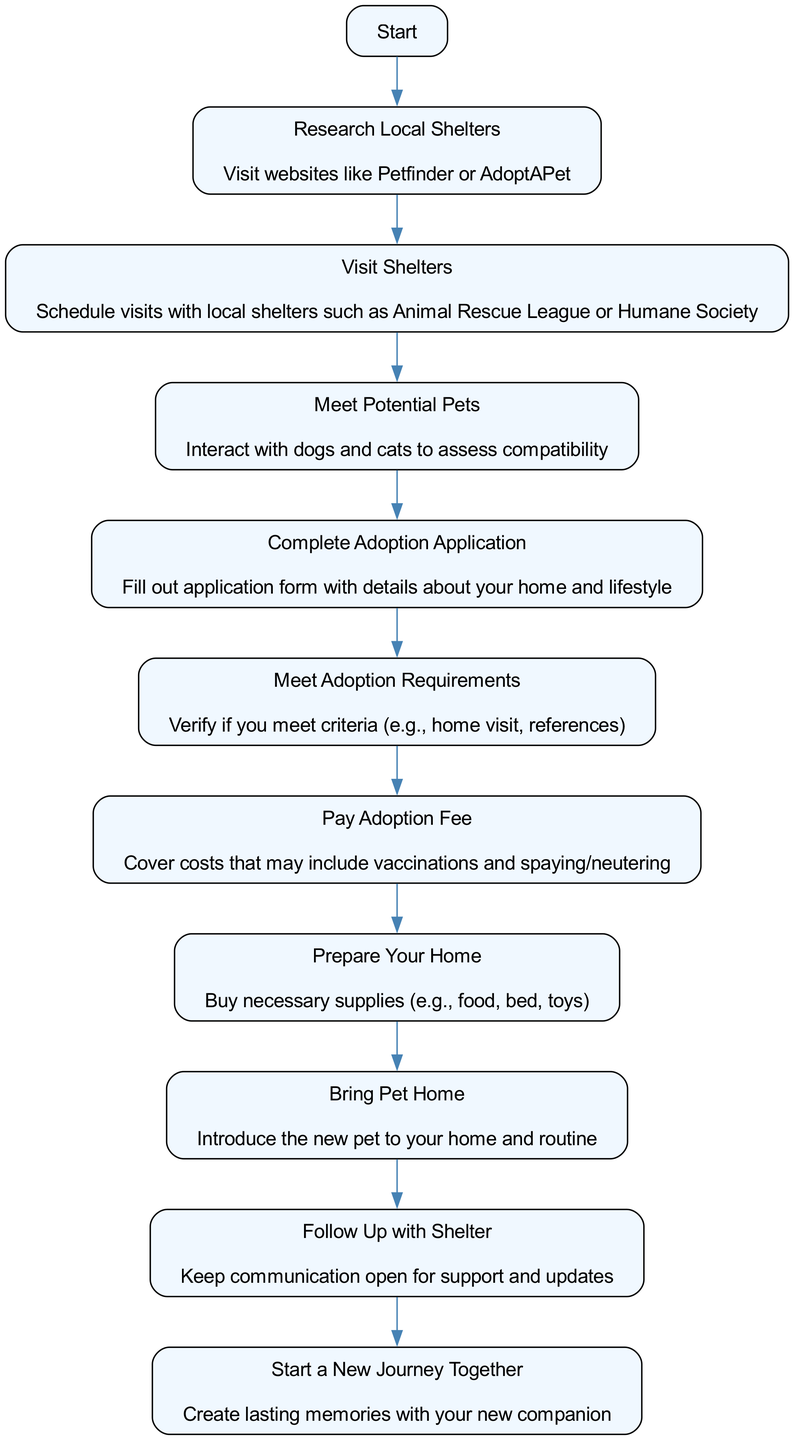What is the first step in the adoption journey? The diagram starts with the step labeled "Start," which indicates the initiation of the pet adoption process.
Answer: Start How many steps are there from research to bringing the pet home? By counting each step in the sequence from "Research Local Shelters" to "Bring Pet Home," there are 8 steps in total.
Answer: 8 What action follows "Visit Shelters"? After "Visit Shelters," the next action is "Meet Potential Pets," which indicates interacting with the animals available for adoption.
Answer: Meet Potential Pets What is required to "Meet Adoption Requirements"? To meet adoption requirements, one must verify if they meet certain criteria, which can include aspects like a home visit and providing references.
Answer: Verify criteria What is the last step before starting a new journey together? The step just before "Start a New Journey Together" is "Follow Up with Shelter," indicating the importance of maintaining communication with the shelter after adoption.
Answer: Follow Up with Shelter How many edges represent the flow of steps in the diagram? Each transition between the steps represents an edge in the diagram, which totals to 9 edges connecting all the steps from start to finish.
Answer: 9 Which action involves preparing your home? The action labeled "Prepare Your Home" involves buying necessary supplies like food, bed, and toys for the new pet.
Answer: Prepare Your Home What is the last action listed in the diagram? The final action in the diagram is "Create lasting memories with your new companion," highlighting the emotional aspect of pet adoption.
Answer: Create lasting memories with your new companion 